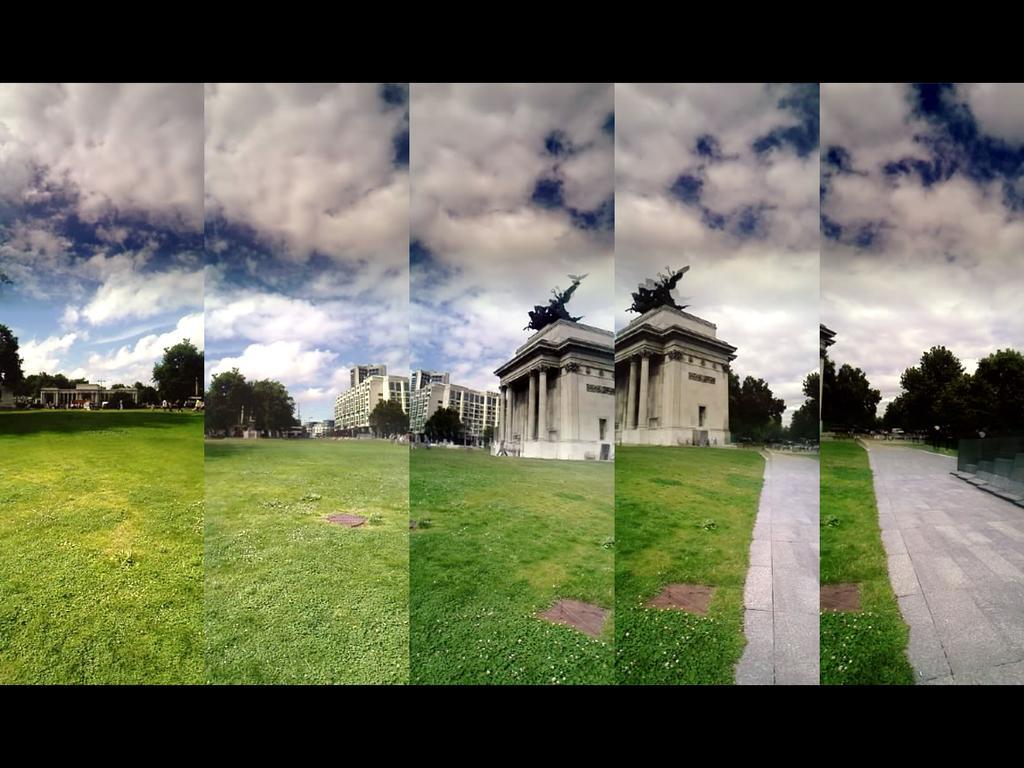In one or two sentences, can you explain what this image depicts? This is a collage picture. I can see buildings, grass, trees, and in the background there is sky. 